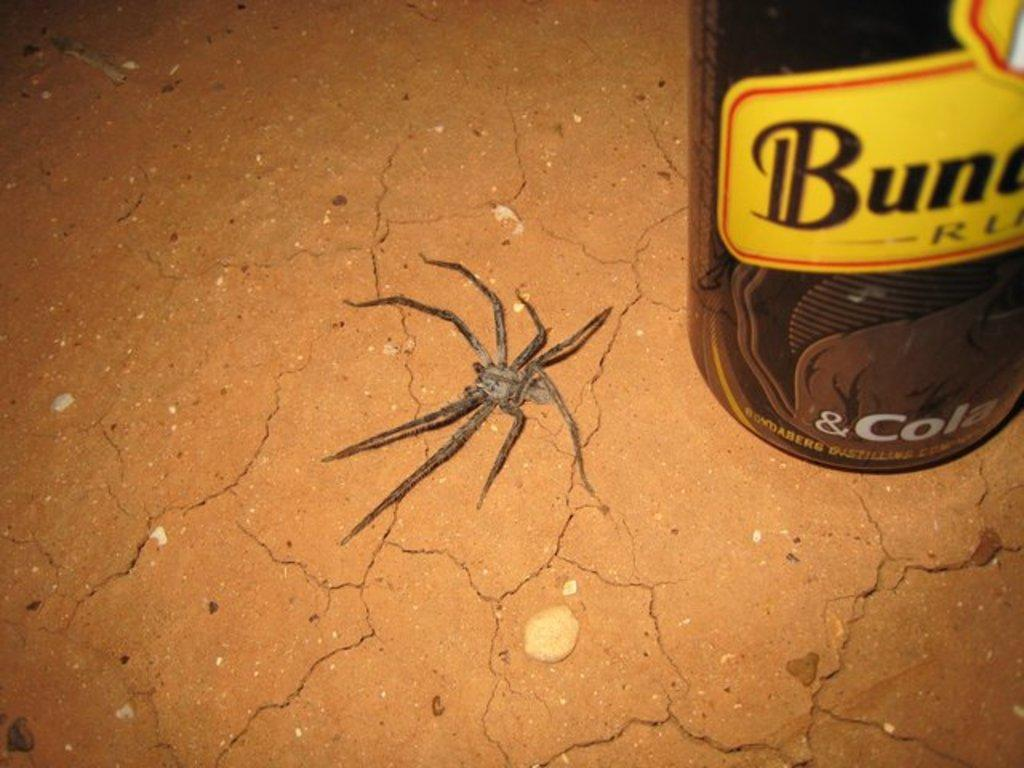What is the main subject in the center of the image? There is a spider in the center of the image. What object can be seen on the right side of the image? There is a bottle on the right side of the image. What type of surface is visible in the background of the image? The background of the image includes the floor. Can you see a river flowing in the background of the image? No, there is no river visible in the image. What type of pencil is being used by the spider in the image? There is no pencil present in the image; it features a spider and a bottle. 